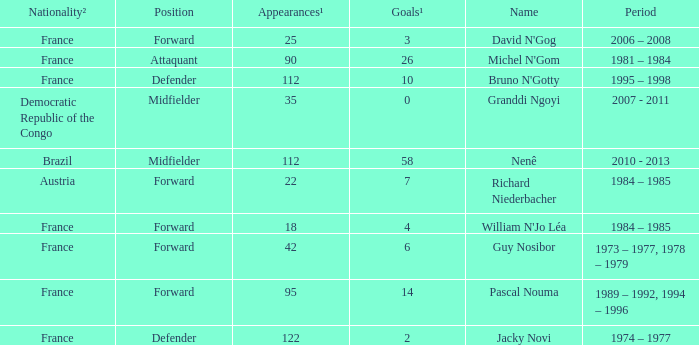List the player that scored 4 times. William N'Jo Léa. 